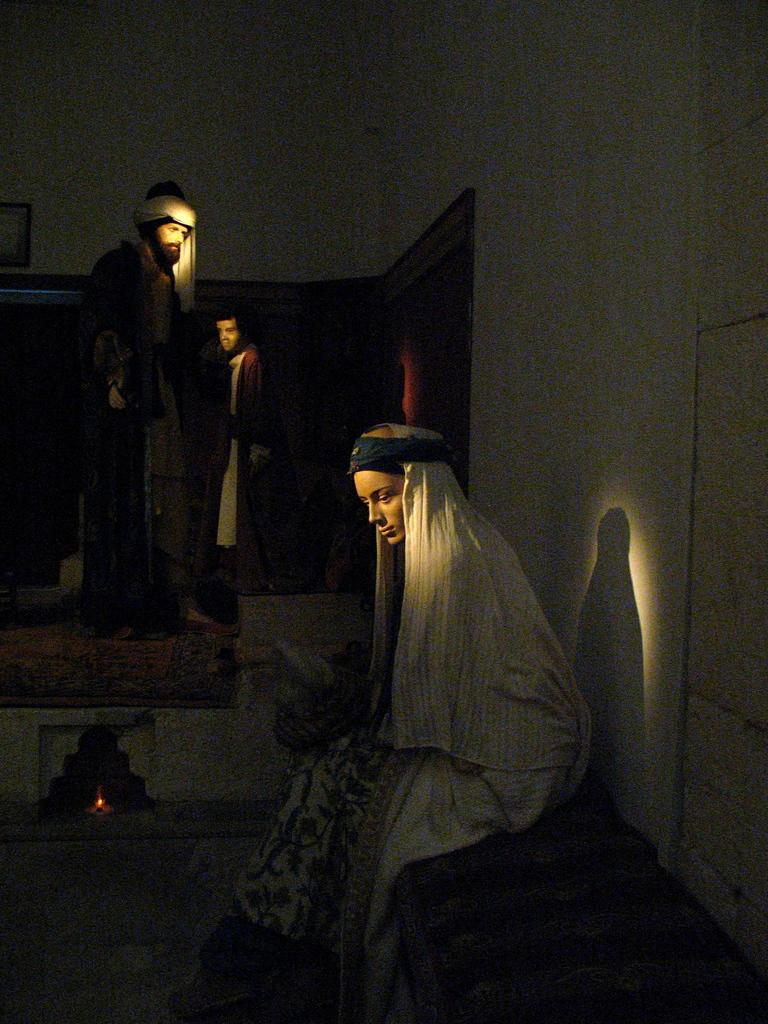What type of objects are in the image? There are statues in the image. What type of surface is visible in the image? There is ground visible in the image. What can be seen providing illumination in the image? There are lights in the image. What type of structure is present in the image? There is a wall with an object in the image. What type of connection is required to use the apparel in the image? There is no apparel present in the image; it features statues, ground, lights, and a wall with an object. How many giants are visible in the image? There are no giants present in the image. 